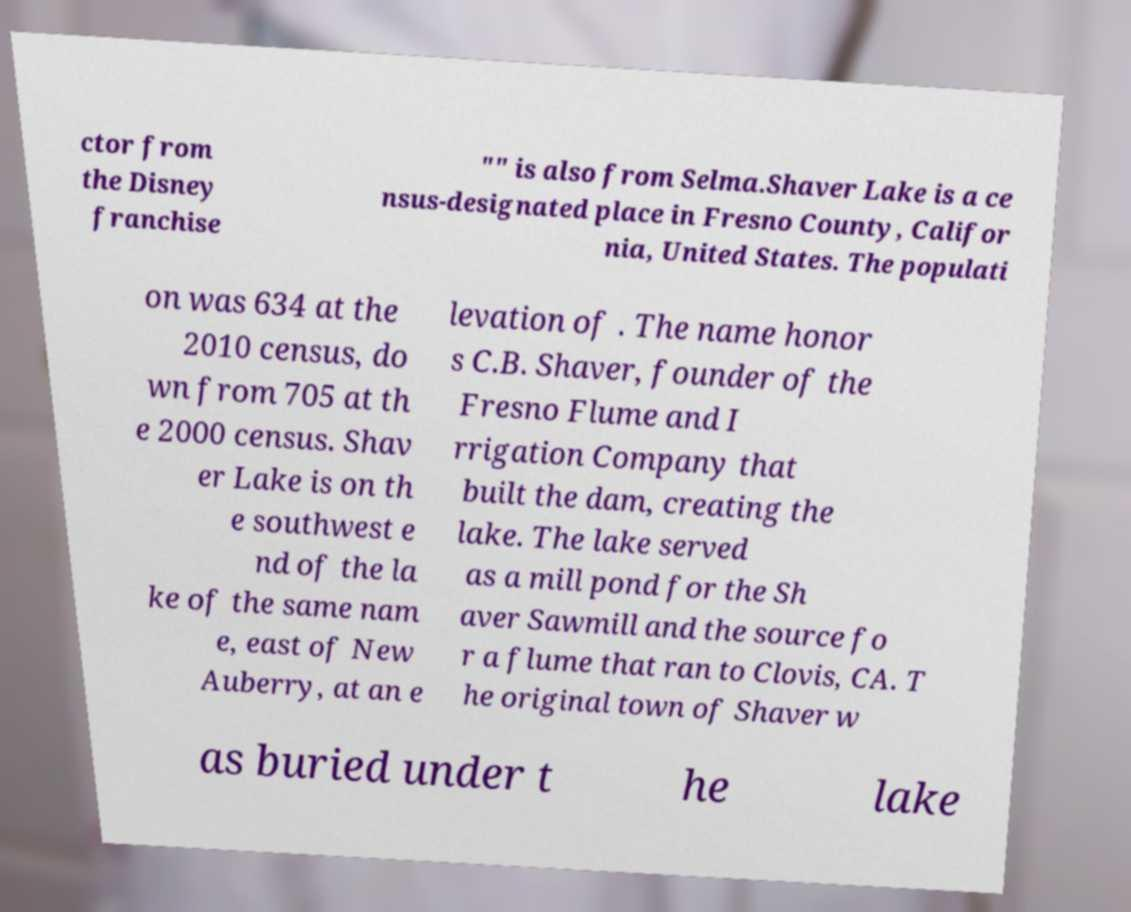Can you read and provide the text displayed in the image?This photo seems to have some interesting text. Can you extract and type it out for me? ctor from the Disney franchise "" is also from Selma.Shaver Lake is a ce nsus-designated place in Fresno County, Califor nia, United States. The populati on was 634 at the 2010 census, do wn from 705 at th e 2000 census. Shav er Lake is on th e southwest e nd of the la ke of the same nam e, east of New Auberry, at an e levation of . The name honor s C.B. Shaver, founder of the Fresno Flume and I rrigation Company that built the dam, creating the lake. The lake served as a mill pond for the Sh aver Sawmill and the source fo r a flume that ran to Clovis, CA. T he original town of Shaver w as buried under t he lake 